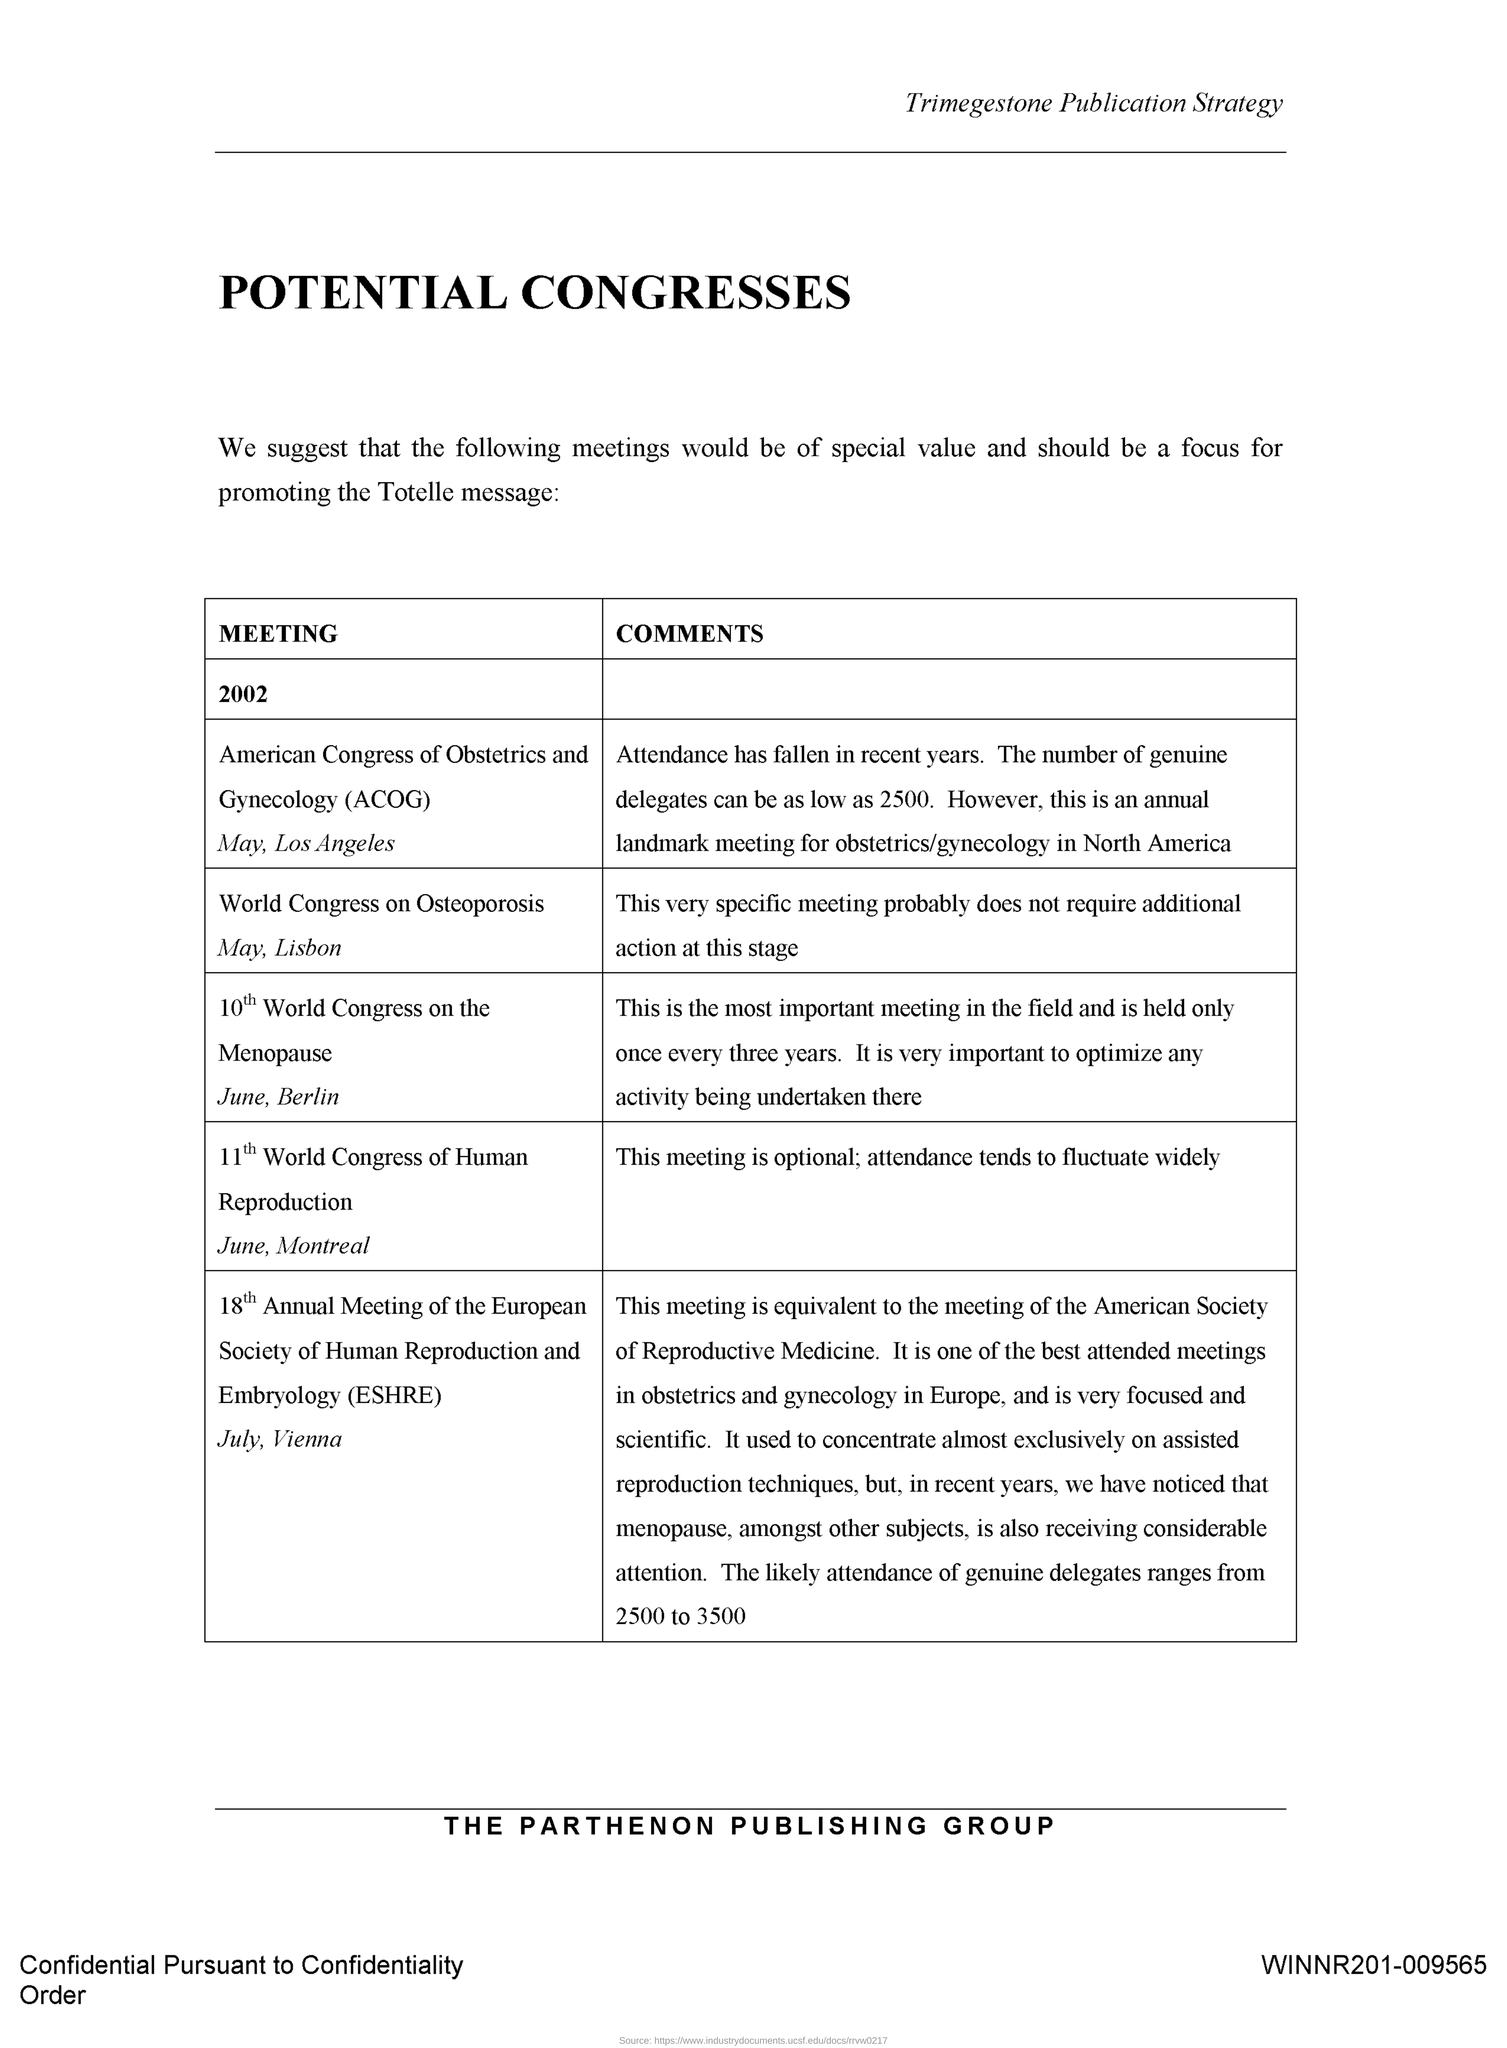Draw attention to some important aspects in this diagram. The World Congress on Osteoporosis will be held in Lisbon. The title located at the bottom of the document is "The Parthenon Publishing Group". The 11th World Congress of Human Reproduction will take place in Montreal. The title "Trimegestone Publication Strategy" is located at the header of the document. 